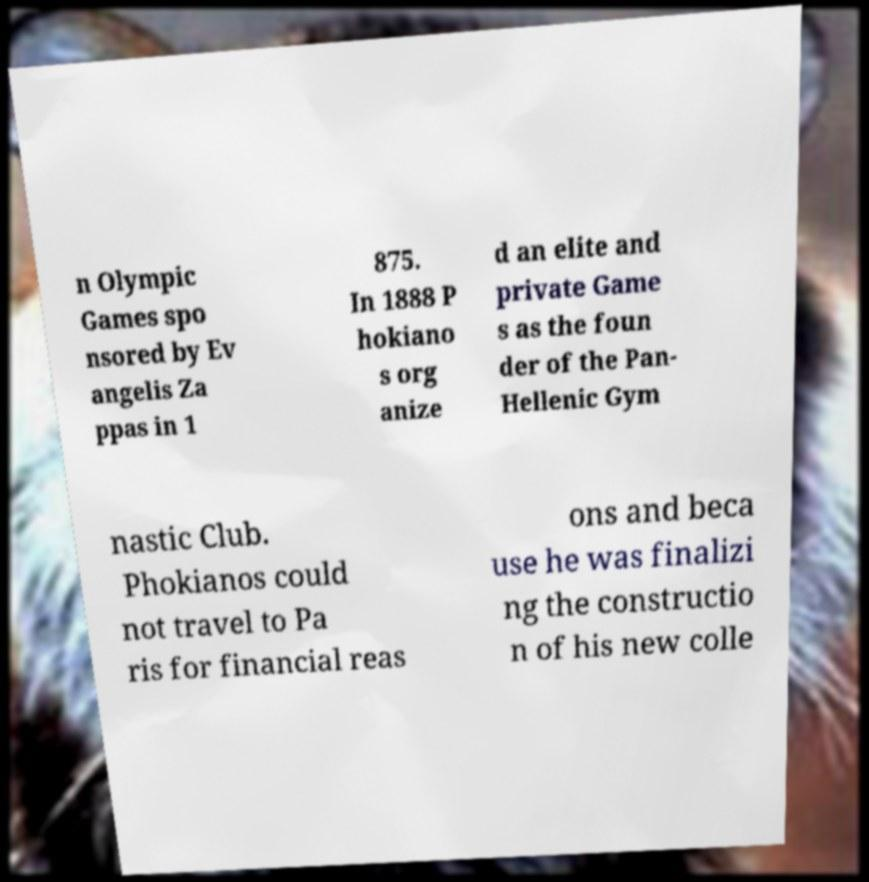Can you accurately transcribe the text from the provided image for me? n Olympic Games spo nsored by Ev angelis Za ppas in 1 875. In 1888 P hokiano s org anize d an elite and private Game s as the foun der of the Pan- Hellenic Gym nastic Club. Phokianos could not travel to Pa ris for financial reas ons and beca use he was finalizi ng the constructio n of his new colle 